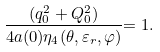Convert formula to latex. <formula><loc_0><loc_0><loc_500><loc_500>\frac { ( q _ { 0 } ^ { 2 } + Q _ { 0 } ^ { 2 } ) } { 4 a ( 0 ) \eta _ { 4 } ( \theta , \varepsilon _ { r } , \varphi ) } { = 1 . }</formula> 